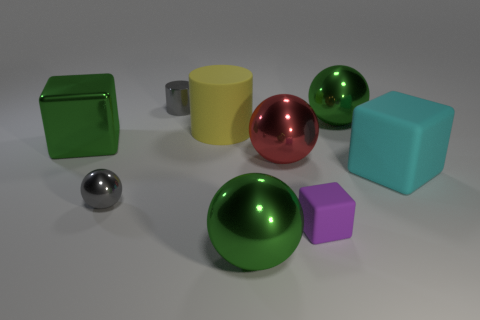Subtract all rubber cubes. How many cubes are left? 1 Add 1 green balls. How many objects exist? 10 Subtract all yellow cylinders. How many cylinders are left? 1 Subtract all cylinders. How many objects are left? 7 Add 7 small gray spheres. How many small gray spheres are left? 8 Add 6 large green spheres. How many large green spheres exist? 8 Subtract 1 green cubes. How many objects are left? 8 Subtract 2 cylinders. How many cylinders are left? 0 Subtract all purple cubes. Subtract all blue spheres. How many cubes are left? 2 Subtract all blue cylinders. How many green balls are left? 2 